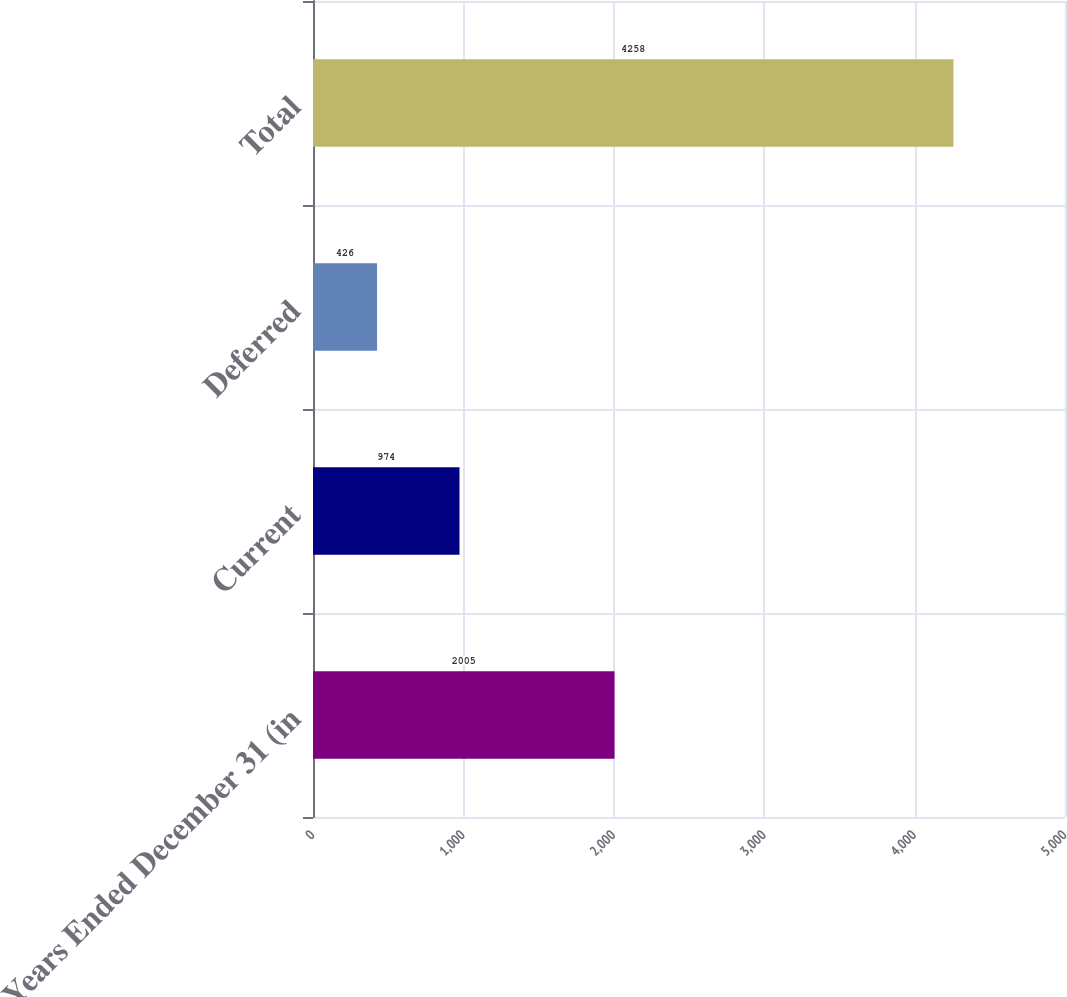Convert chart. <chart><loc_0><loc_0><loc_500><loc_500><bar_chart><fcel>Years Ended December 31 (in<fcel>Current<fcel>Deferred<fcel>Total<nl><fcel>2005<fcel>974<fcel>426<fcel>4258<nl></chart> 